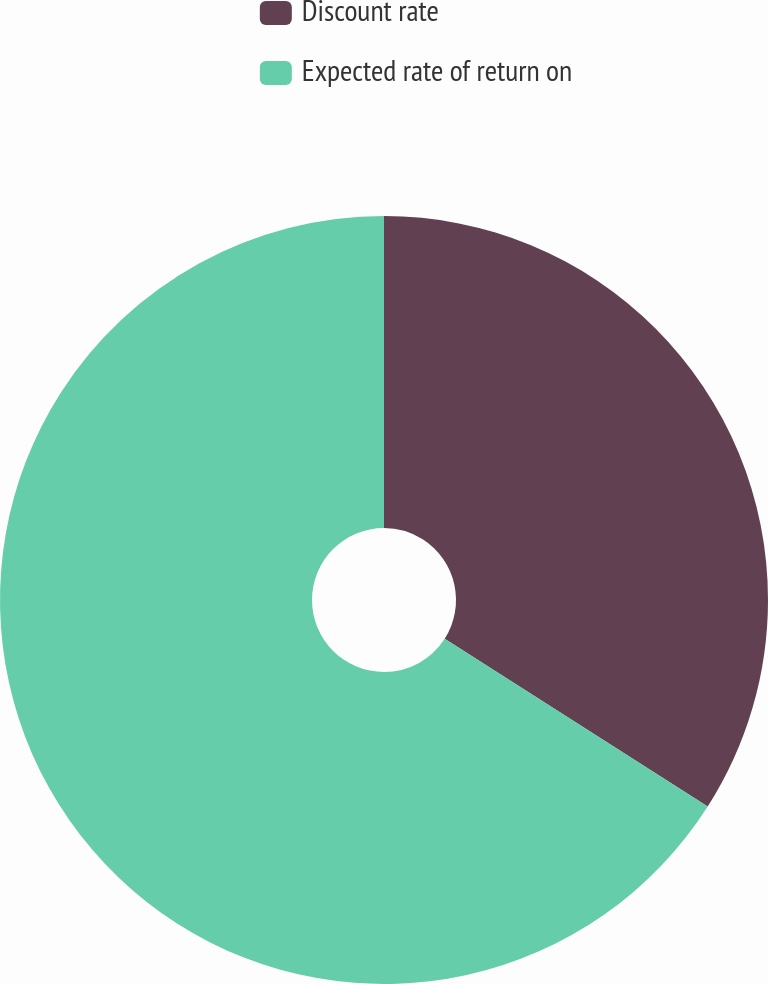<chart> <loc_0><loc_0><loc_500><loc_500><pie_chart><fcel>Discount rate<fcel>Expected rate of return on<nl><fcel>34.04%<fcel>65.96%<nl></chart> 